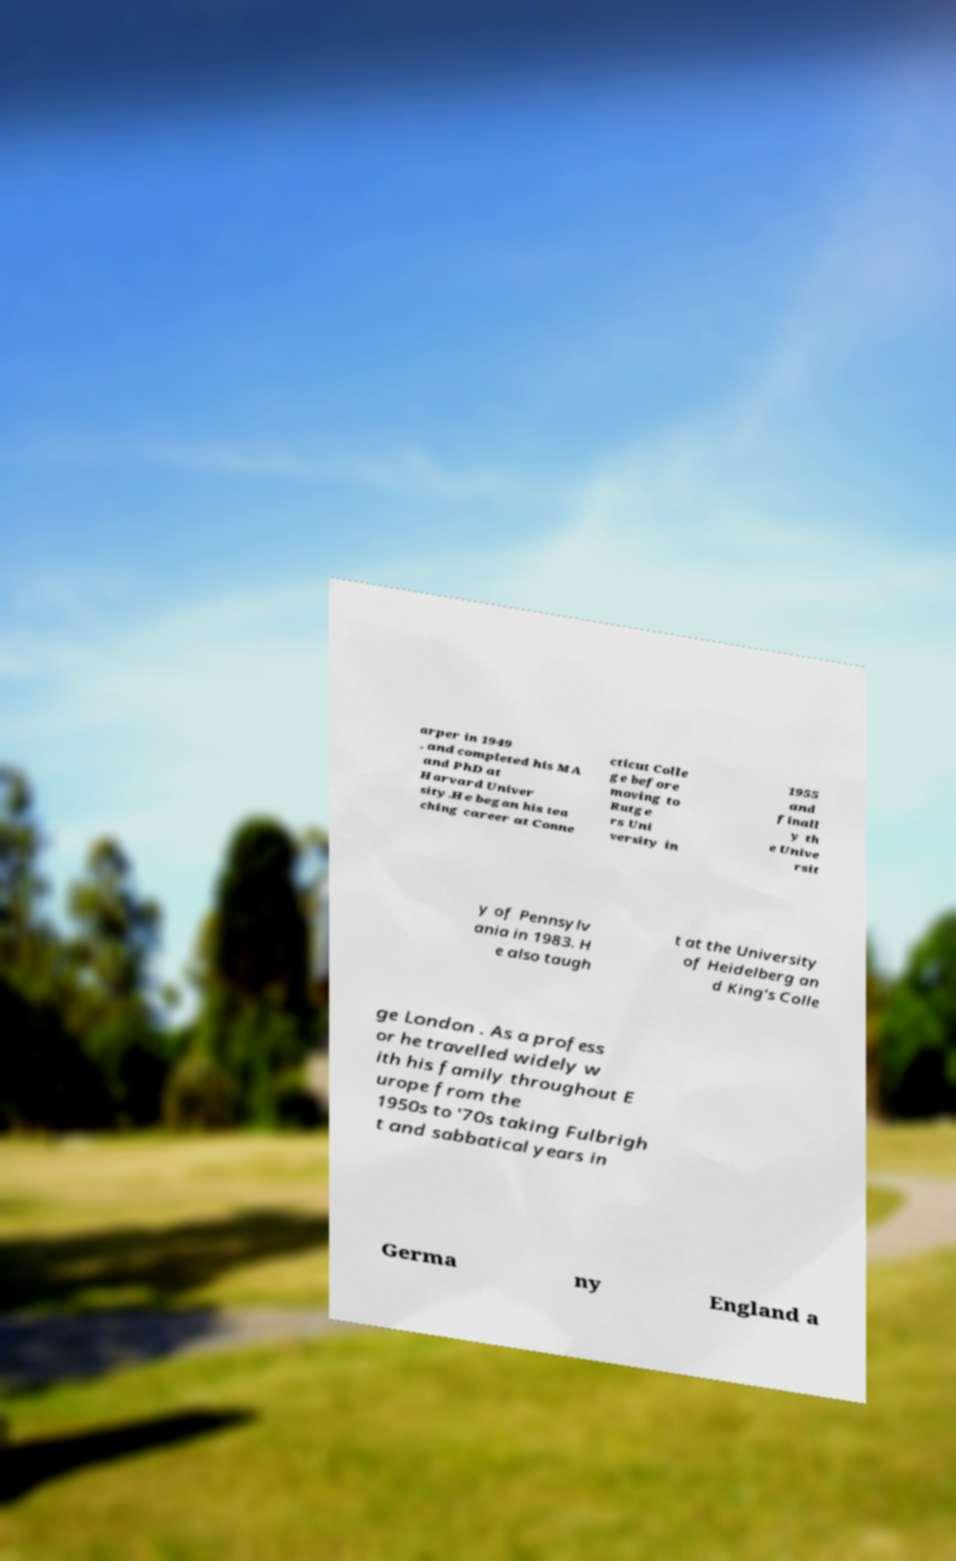Please identify and transcribe the text found in this image. arper in 1949 , and completed his MA and PhD at Harvard Univer sity.He began his tea ching career at Conne cticut Colle ge before moving to Rutge rs Uni versity in 1955 and finall y th e Unive rsit y of Pennsylv ania in 1983. H e also taugh t at the University of Heidelberg an d King's Colle ge London . As a profess or he travelled widely w ith his family throughout E urope from the 1950s to '70s taking Fulbrigh t and sabbatical years in Germa ny England a 